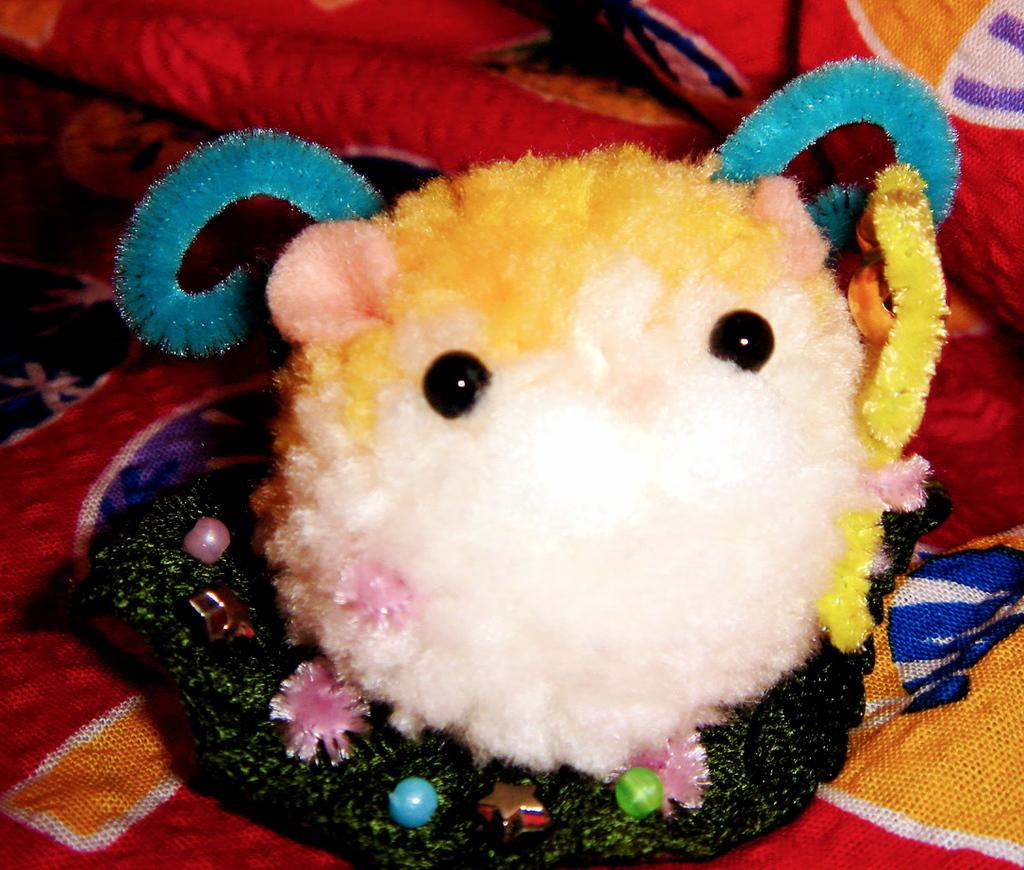What object can be seen in the image? There is a toy in the image. What is the toy placed on? The toy is on a red color cloth. What type of alley is visible in the image? There is no alley present in the image; it only features a toy on a red color cloth. 